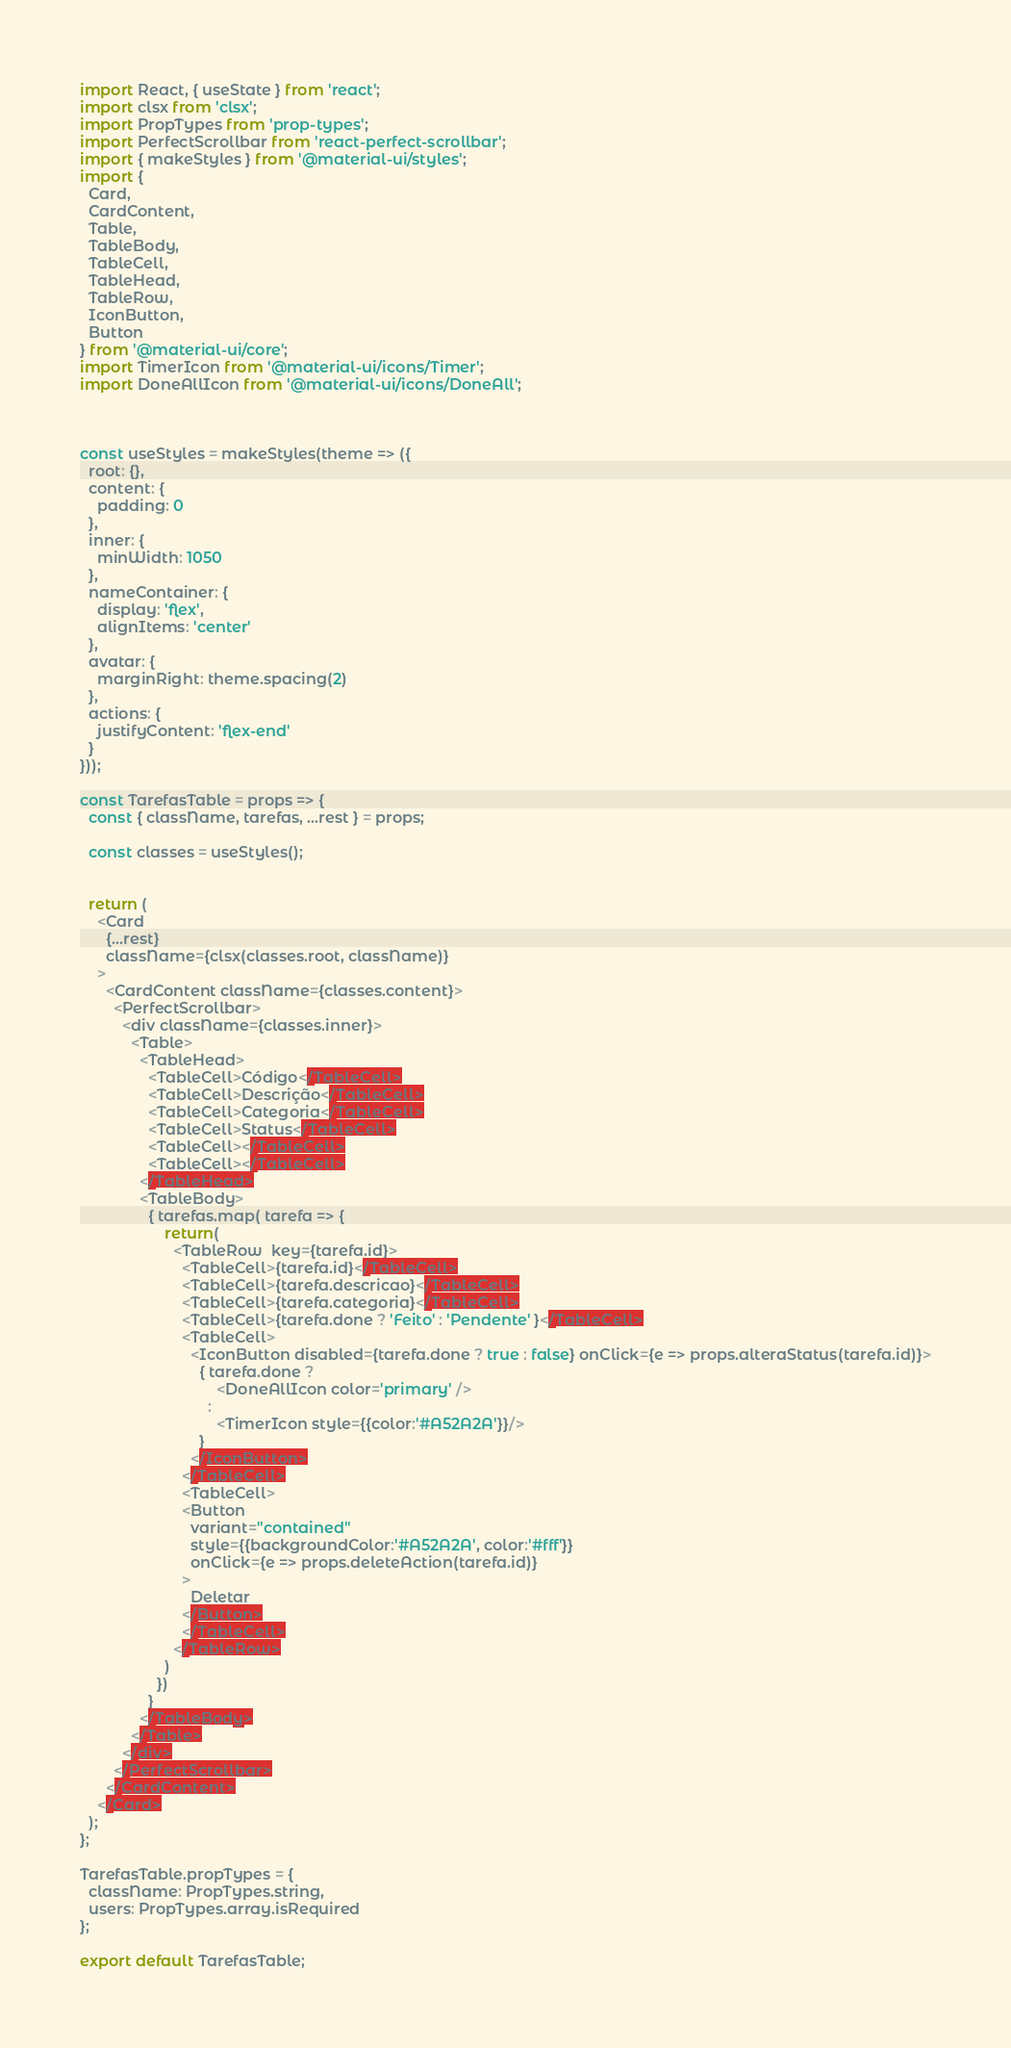<code> <loc_0><loc_0><loc_500><loc_500><_JavaScript_>import React, { useState } from 'react';
import clsx from 'clsx';
import PropTypes from 'prop-types';
import PerfectScrollbar from 'react-perfect-scrollbar';
import { makeStyles } from '@material-ui/styles';
import {
  Card,
  CardContent,
  Table,
  TableBody,
  TableCell,
  TableHead,
  TableRow,
  IconButton,
  Button
} from '@material-ui/core';
import TimerIcon from '@material-ui/icons/Timer';
import DoneAllIcon from '@material-ui/icons/DoneAll';



const useStyles = makeStyles(theme => ({
  root: {},
  content: {
    padding: 0
  },
  inner: {
    minWidth: 1050
  },
  nameContainer: {
    display: 'flex',
    alignItems: 'center'
  },
  avatar: {
    marginRight: theme.spacing(2)
  },
  actions: {
    justifyContent: 'flex-end'
  }
}));

const TarefasTable = props => {
  const { className, tarefas, ...rest } = props;

  const classes = useStyles();


  return (
    <Card
      {...rest}
      className={clsx(classes.root, className)}
    >
      <CardContent className={classes.content}>
        <PerfectScrollbar>
          <div className={classes.inner}>
            <Table>
              <TableHead>
                <TableCell>Código</TableCell>
                <TableCell>Descrição</TableCell>
                <TableCell>Categoria</TableCell>
                <TableCell>Status</TableCell>
                <TableCell></TableCell>
                <TableCell></TableCell>
              </TableHead>
              <TableBody>
                { tarefas.map( tarefa => {
                    return(
                      <TableRow  key={tarefa.id}>
                        <TableCell>{tarefa.id}</TableCell>
                        <TableCell>{tarefa.descricao}</TableCell>
                        <TableCell>{tarefa.categoria}</TableCell>
                        <TableCell>{tarefa.done ? 'Feito' : 'Pendente' }</TableCell>
                        <TableCell>
                          <IconButton disabled={tarefa.done ? true : false} onClick={e => props.alteraStatus(tarefa.id)}>
                            { tarefa.done ? 
                                <DoneAllIcon color='primary' />
                              :
                                <TimerIcon style={{color:'#A52A2A'}}/>
                            }
                          </IconButton>
                        </TableCell>
                        <TableCell>
                        <Button 
                          variant="contained" 
                          style={{backgroundColor:'#A52A2A', color:'#fff'}}
                          onClick={e => props.deleteAction(tarefa.id)}
                        >
                          Deletar
                        </Button>
                        </TableCell>
                      </TableRow>
                    )
                  })
                }
              </TableBody>
            </Table>
          </div>
        </PerfectScrollbar>
      </CardContent>
    </Card>
  );
};

TarefasTable.propTypes = {
  className: PropTypes.string,
  users: PropTypes.array.isRequired
};

export default TarefasTable;
</code> 